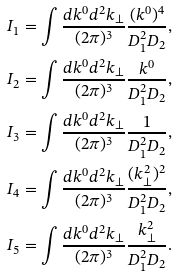<formula> <loc_0><loc_0><loc_500><loc_500>I _ { 1 } & = \int \frac { d k ^ { 0 } d ^ { 2 } k _ { \perp } } { ( 2 \pi ) ^ { 3 } } \frac { ( k ^ { 0 } ) ^ { 4 } } { D ^ { 2 } _ { 1 } D _ { 2 } } , \\ I _ { 2 } & = \int \frac { d k ^ { 0 } d ^ { 2 } k _ { \perp } } { ( 2 \pi ) ^ { 3 } } \frac { k ^ { 0 } } { D ^ { 2 } _ { 1 } D _ { 2 } } , \\ I _ { 3 } & = \int \frac { d k ^ { 0 } d ^ { 2 } k _ { \perp } } { ( 2 \pi ) ^ { 3 } } \frac { 1 } { D ^ { 2 } _ { 1 } D _ { 2 } } , \\ I _ { 4 } & = \int \frac { d k ^ { 0 } d ^ { 2 } k _ { \perp } } { ( 2 \pi ) ^ { 3 } } \frac { ( k ^ { 2 } _ { \perp } ) ^ { 2 } } { D ^ { 2 } _ { 1 } D _ { 2 } } , \\ I _ { 5 } & = \int \frac { d k ^ { 0 } d ^ { 2 } k _ { \perp } } { ( 2 \pi ) ^ { 3 } } \frac { k ^ { 2 } _ { \perp } } { D ^ { 2 } _ { 1 } D _ { 2 } } .</formula> 